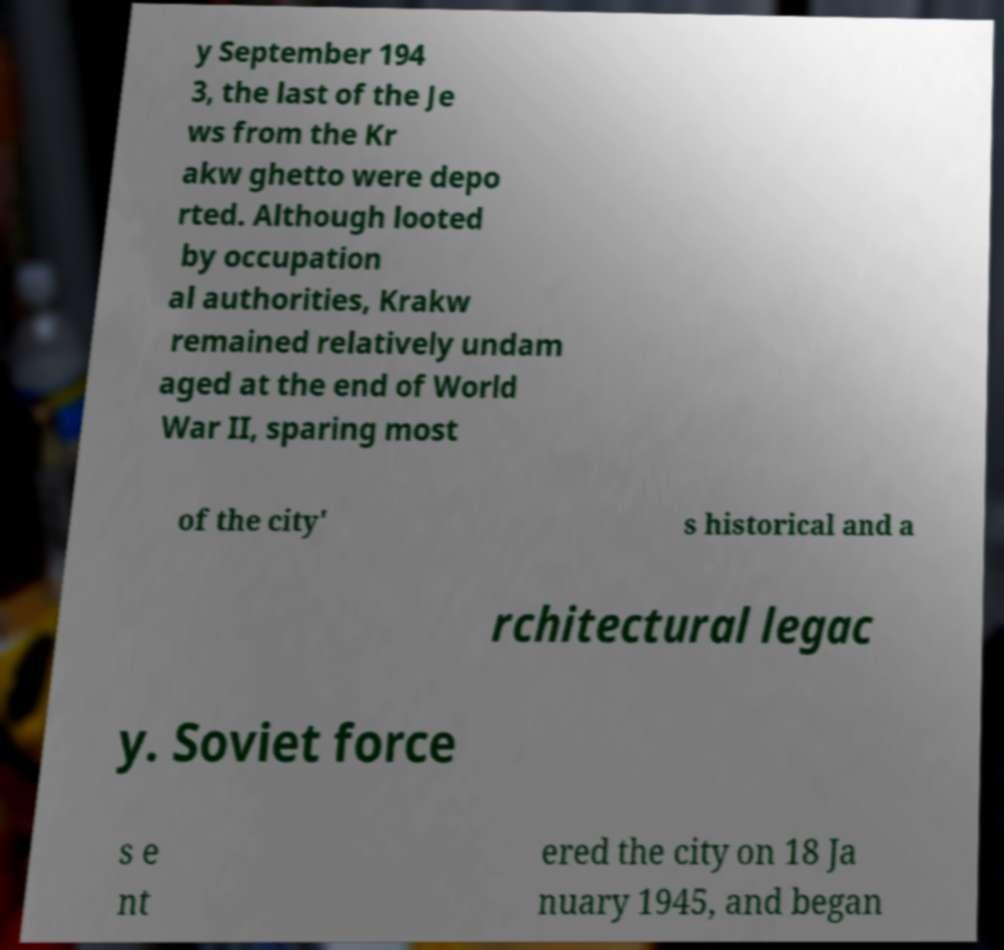I need the written content from this picture converted into text. Can you do that? y September 194 3, the last of the Je ws from the Kr akw ghetto were depo rted. Although looted by occupation al authorities, Krakw remained relatively undam aged at the end of World War II, sparing most of the city' s historical and a rchitectural legac y. Soviet force s e nt ered the city on 18 Ja nuary 1945, and began 